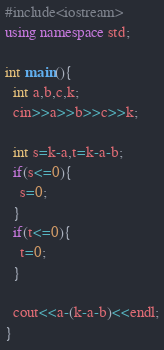Convert code to text. <code><loc_0><loc_0><loc_500><loc_500><_C++_>#include<iostream>
using namespace std;

int main(){
  int a,b,c,k;
  cin>>a>>b>>c>>k;
  
  int s=k-a,t=k-a-b;
  if(s<=0){
    s=0;
  }
  if(t<=0){
    t=0;
  }
  
  cout<<a-(k-a-b)<<endl;
}</code> 